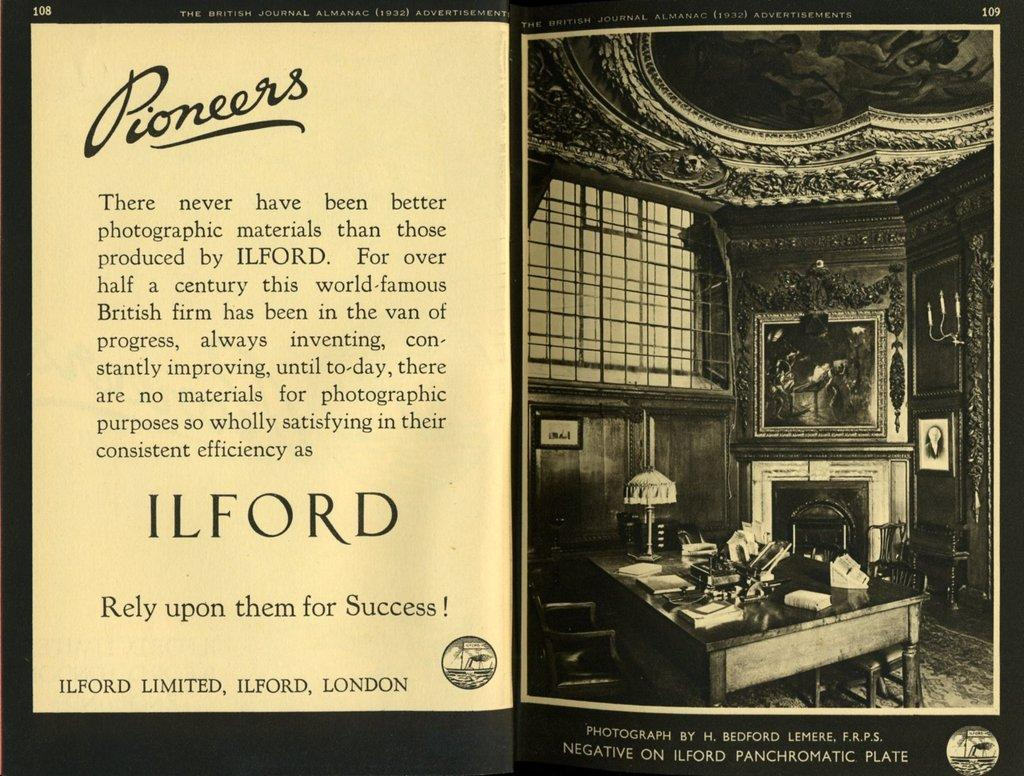<image>
Give a short and clear explanation of the subsequent image. An advertisment in a magazine Ilford photographic materials with the tagline Rely on the for Success. 